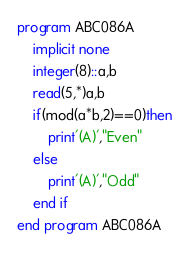<code> <loc_0><loc_0><loc_500><loc_500><_FORTRAN_>program ABC086A
    implicit none
    integer(8)::a,b
    read(5,*)a,b
    if(mod(a*b,2)==0)then
        print'(A)',"Even"
    else
        print'(A)',"Odd"
    end if    
end program ABC086A</code> 